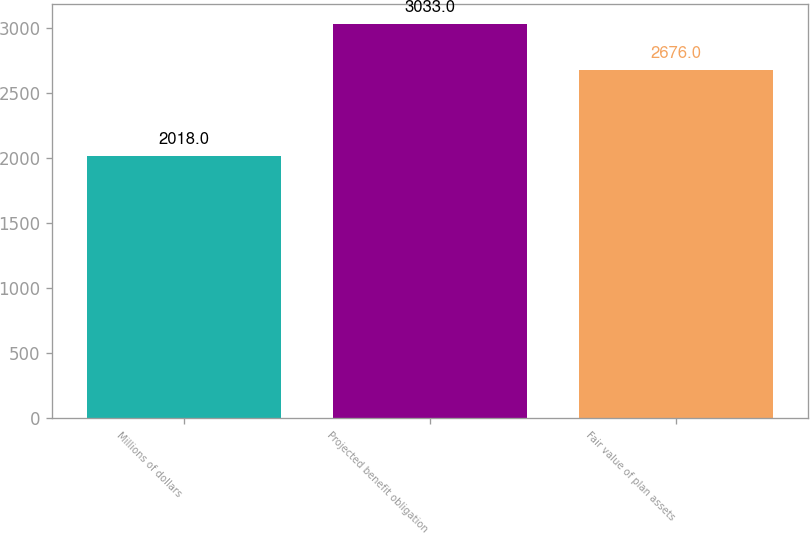Convert chart to OTSL. <chart><loc_0><loc_0><loc_500><loc_500><bar_chart><fcel>Millions of dollars<fcel>Projected benefit obligation<fcel>Fair value of plan assets<nl><fcel>2018<fcel>3033<fcel>2676<nl></chart> 